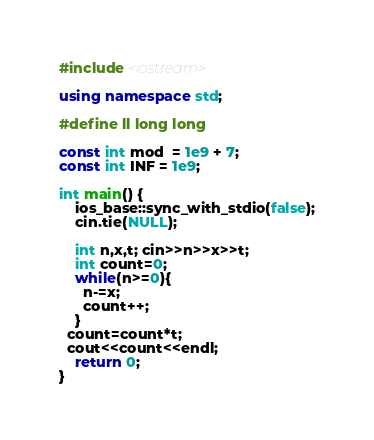<code> <loc_0><loc_0><loc_500><loc_500><_C++_>#include <iostream>

using namespace std;

#define ll long long

const int mod  = 1e9 + 7;
const int INF = 1e9;

int main() {
    ios_base::sync_with_stdio(false);
    cin.tie(NULL);
    
    int n,x,t; cin>>n>>x>>t;
    int count=0;
    while(n>=0){
      n-=x;
      count++;
    }    
  count=count*t;
  cout<<count<<endl;
	return 0;
}


</code> 